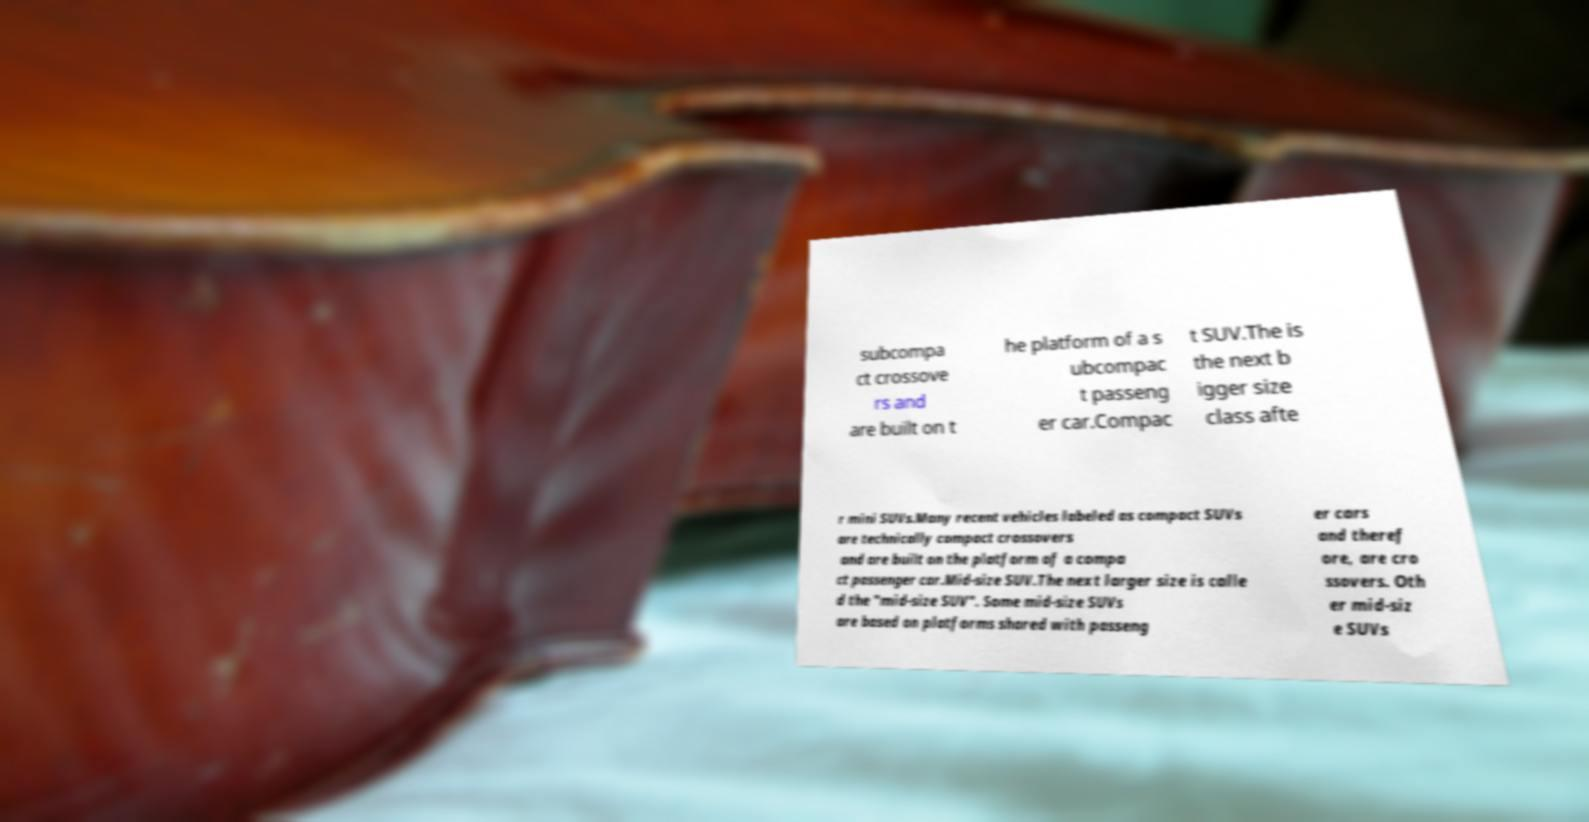Can you accurately transcribe the text from the provided image for me? subcompa ct crossove rs and are built on t he platform of a s ubcompac t passeng er car.Compac t SUV.The is the next b igger size class afte r mini SUVs.Many recent vehicles labeled as compact SUVs are technically compact crossovers and are built on the platform of a compa ct passenger car.Mid-size SUV.The next larger size is calle d the "mid-size SUV". Some mid-size SUVs are based on platforms shared with passeng er cars and theref ore, are cro ssovers. Oth er mid-siz e SUVs 